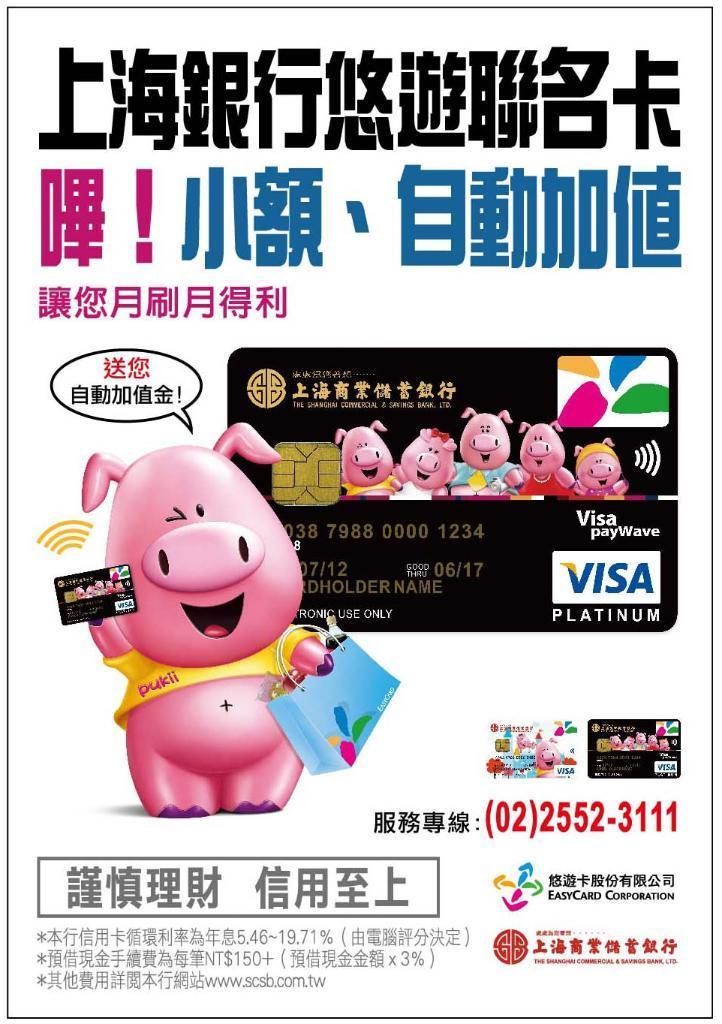Could you give a brief overview of what you see in this image? In this image I can see a poster on which I can see a pig which is pink in color holding a bag and a card and I can see a black colored card. I can see something is written on the poster. 